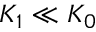<formula> <loc_0><loc_0><loc_500><loc_500>K _ { 1 } \ll K _ { 0 }</formula> 